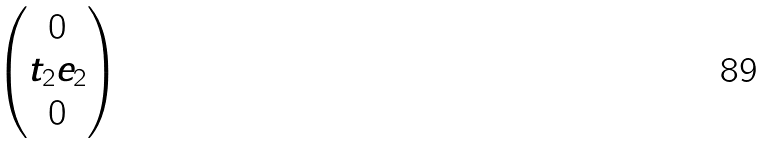<formula> <loc_0><loc_0><loc_500><loc_500>\begin{pmatrix} 0 \\ t _ { 2 } e _ { 2 } \\ 0 \end{pmatrix}</formula> 